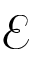Convert formula to latex. <formula><loc_0><loc_0><loc_500><loc_500>\mathcal { E }</formula> 